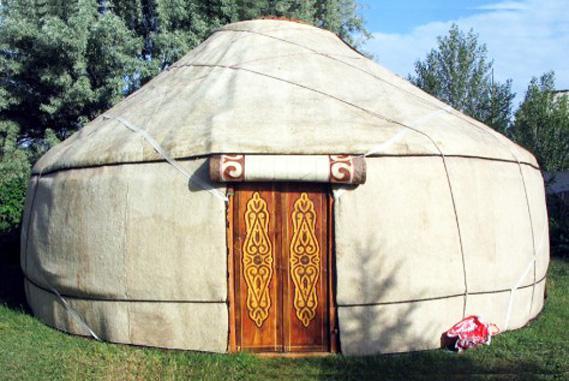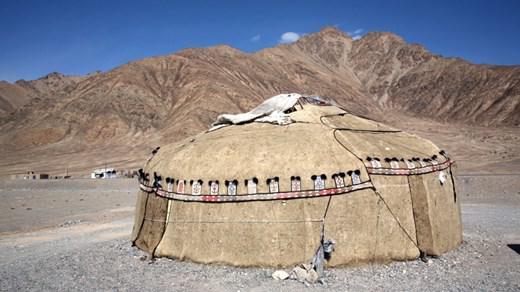The first image is the image on the left, the second image is the image on the right. For the images displayed, is the sentence "At least one person is standing outside the hut in the image on the left." factually correct? Answer yes or no. No. The first image is the image on the left, the second image is the image on the right. For the images displayed, is the sentence "A single white yurt is photographed with its door facing directly toward the camera, and at least one person stands outside the doorway." factually correct? Answer yes or no. No. 